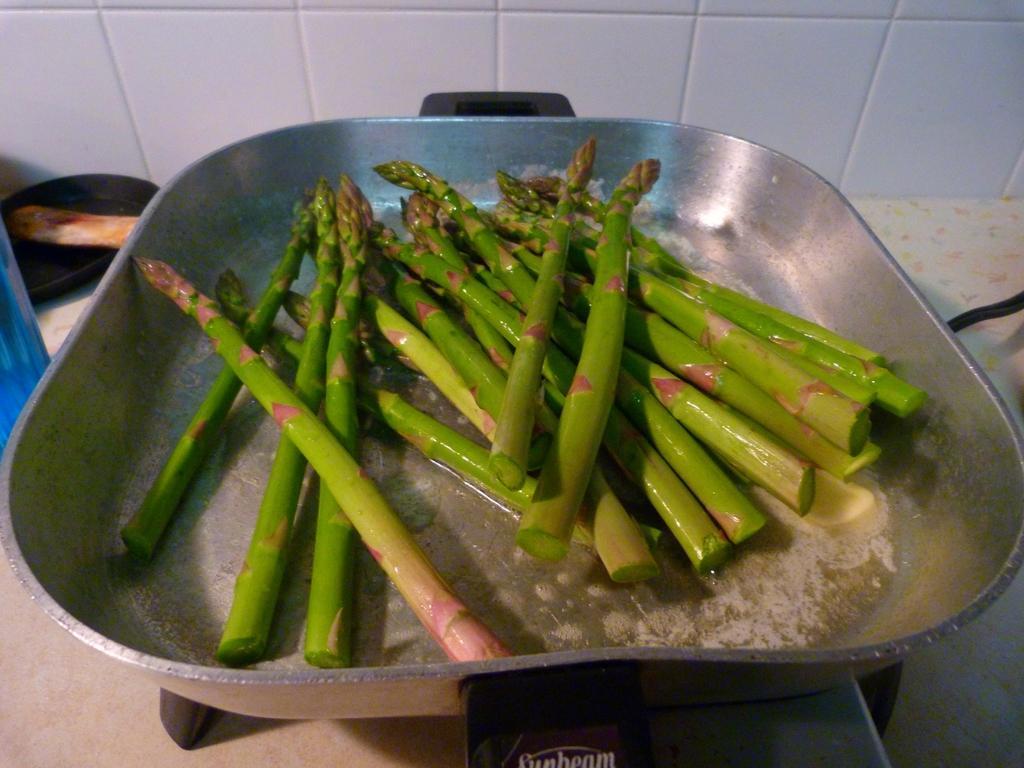Describe this image in one or two sentences. In this image I can see a gas stove and on the gas stove I can see a metal bowl. In the bowl I can see few green colored objects and in the background I can see the white colored wall and few other objects. 